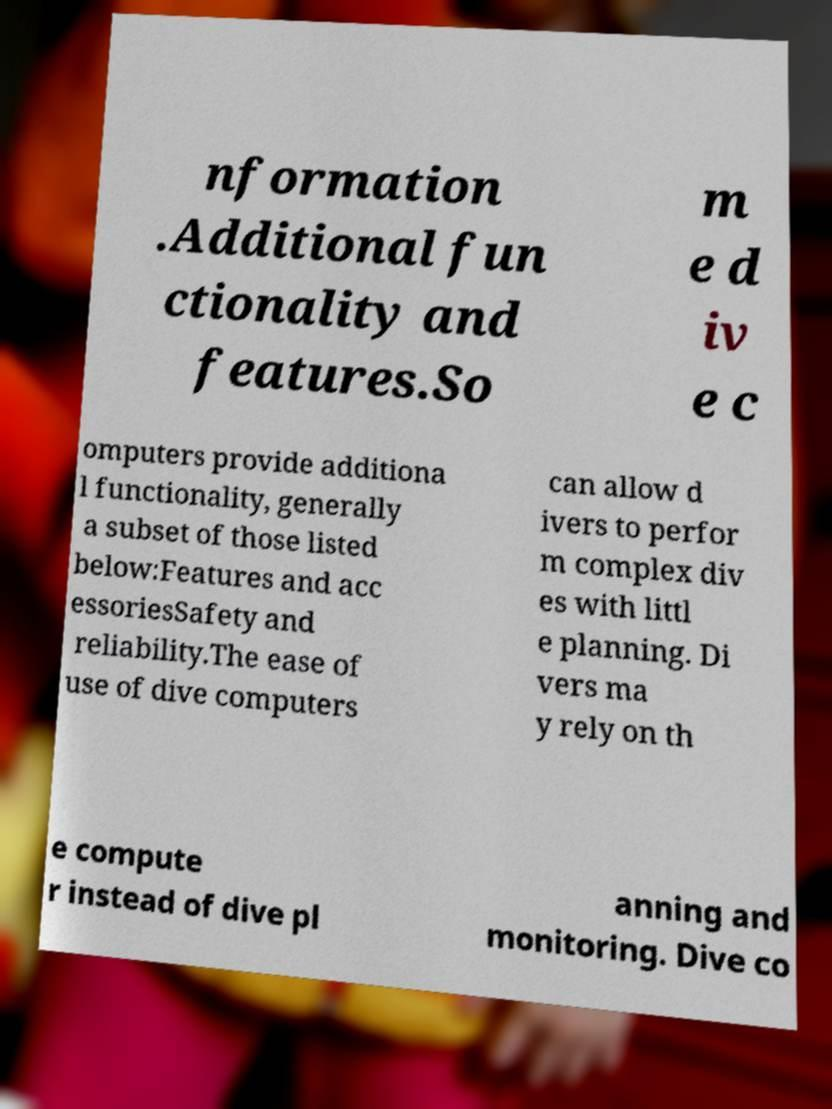Please identify and transcribe the text found in this image. nformation .Additional fun ctionality and features.So m e d iv e c omputers provide additiona l functionality, generally a subset of those listed below:Features and acc essoriesSafety and reliability.The ease of use of dive computers can allow d ivers to perfor m complex div es with littl e planning. Di vers ma y rely on th e compute r instead of dive pl anning and monitoring. Dive co 